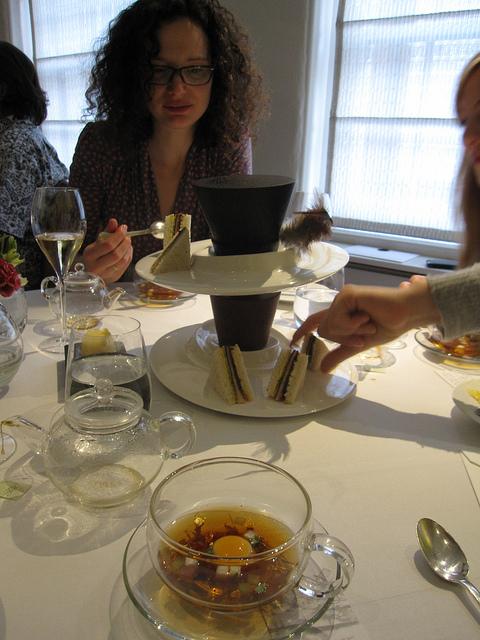Is this a nice restaurant?
Quick response, please. Yes. What is the woman reaching for?
Write a very short answer. Sandwich. Which utensil is on the table in the foreground?
Write a very short answer. Spoon. 